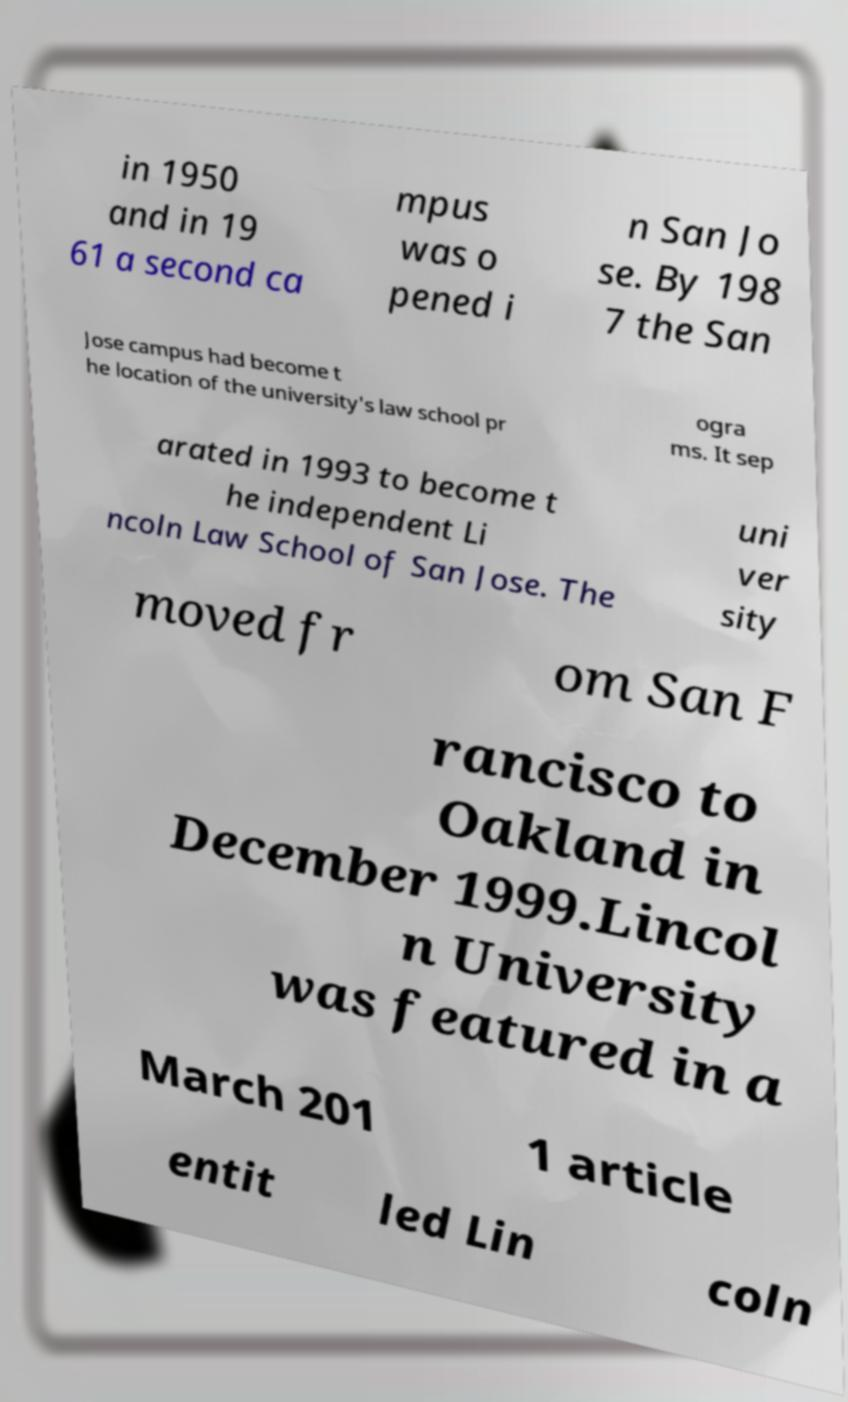There's text embedded in this image that I need extracted. Can you transcribe it verbatim? in 1950 and in 19 61 a second ca mpus was o pened i n San Jo se. By 198 7 the San Jose campus had become t he location of the university's law school pr ogra ms. It sep arated in 1993 to become t he independent Li ncoln Law School of San Jose. The uni ver sity moved fr om San F rancisco to Oakland in December 1999.Lincol n University was featured in a March 201 1 article entit led Lin coln 